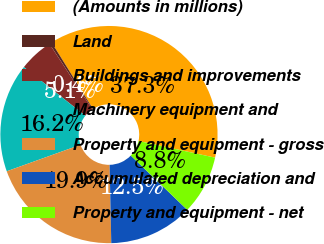Convert chart. <chart><loc_0><loc_0><loc_500><loc_500><pie_chart><fcel>(Amounts in millions)<fcel>Land<fcel>Buildings and improvements<fcel>Machinery equipment and<fcel>Property and equipment - gross<fcel>Accumulated depreciation and<fcel>Property and equipment - net<nl><fcel>37.26%<fcel>0.37%<fcel>5.09%<fcel>16.16%<fcel>19.85%<fcel>12.47%<fcel>8.78%<nl></chart> 